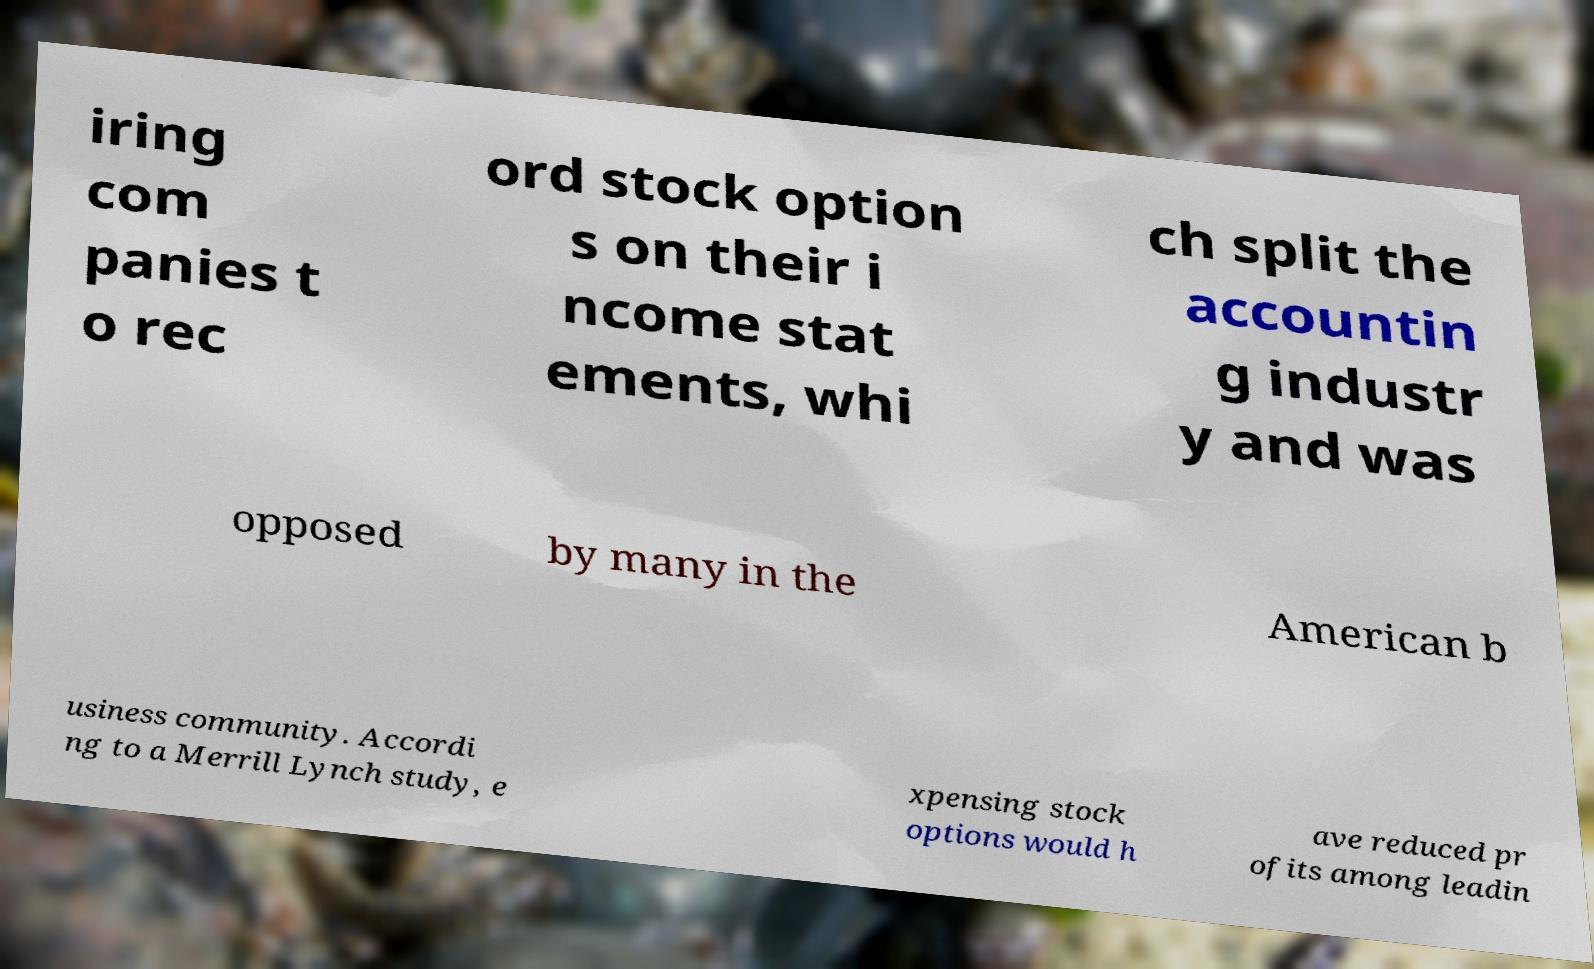Please read and relay the text visible in this image. What does it say? iring com panies t o rec ord stock option s on their i ncome stat ements, whi ch split the accountin g industr y and was opposed by many in the American b usiness community. Accordi ng to a Merrill Lynch study, e xpensing stock options would h ave reduced pr ofits among leadin 